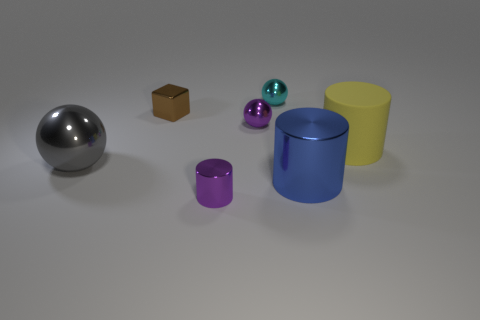Can you compare the size of the objects? Certainly, starting from the left, the sphere appears to be the largest object followed by the yellow cylinder. The tiny brown box and the small purple objects (a cylinder and a sphere) are the smallest. The blue cylinder falls in between the largest and the smallest objects in terms of size. 